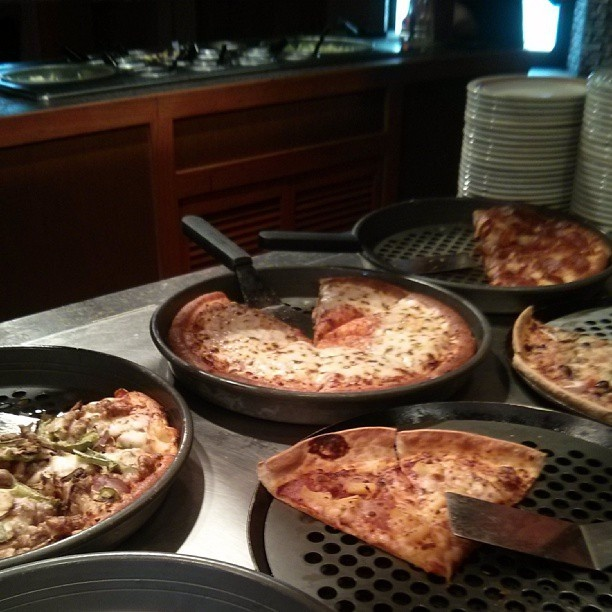Describe the objects in this image and their specific colors. I can see oven in black, gray, darkgray, and ivory tones, pizza in black, brown, tan, red, and maroon tones, pizza in black, gray, maroon, and tan tones, pizza in black, tan, and brown tones, and pizza in black, maroon, and gray tones in this image. 